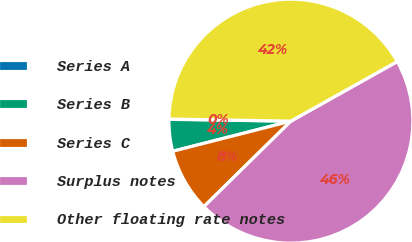<chart> <loc_0><loc_0><loc_500><loc_500><pie_chart><fcel>Series A<fcel>Series B<fcel>Series C<fcel>Surplus notes<fcel>Other floating rate notes<nl><fcel>0.04%<fcel>4.21%<fcel>8.39%<fcel>45.77%<fcel>41.59%<nl></chart> 